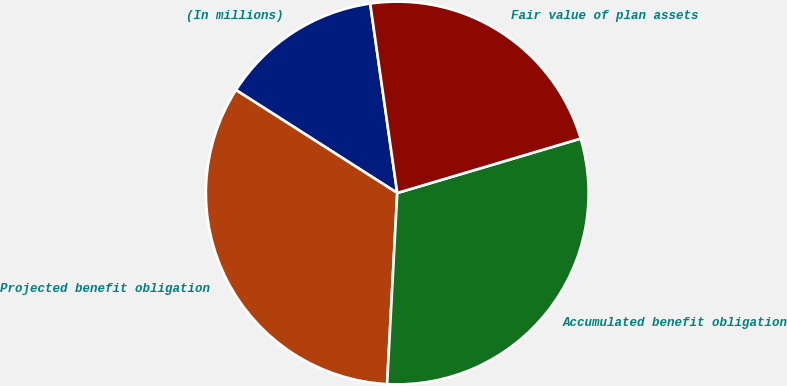<chart> <loc_0><loc_0><loc_500><loc_500><pie_chart><fcel>(In millions)<fcel>Projected benefit obligation<fcel>Accumulated benefit obligation<fcel>Fair value of plan assets<nl><fcel>13.7%<fcel>33.2%<fcel>30.44%<fcel>22.67%<nl></chart> 